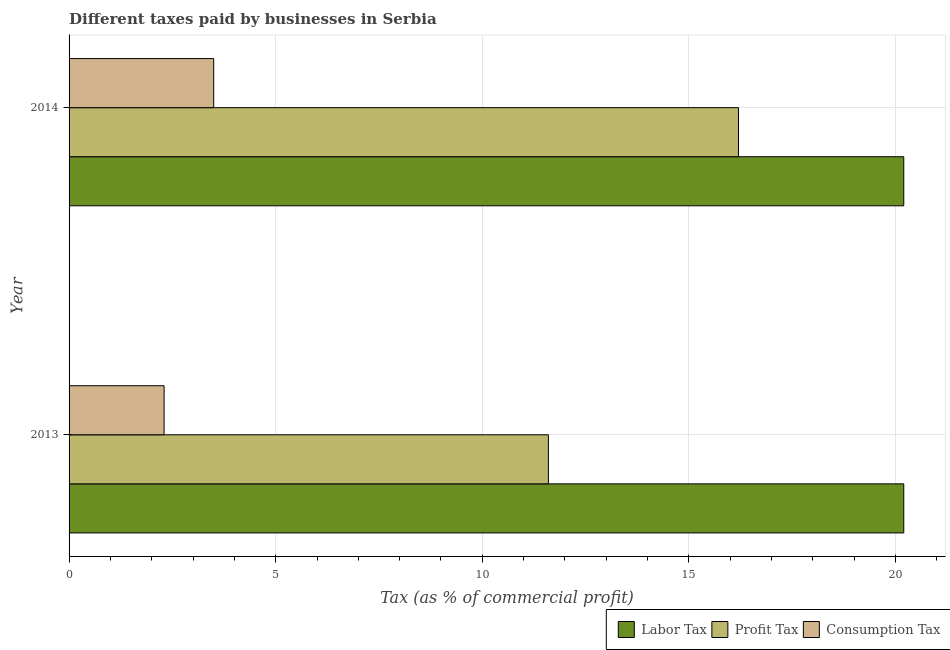Are the number of bars per tick equal to the number of legend labels?
Keep it short and to the point. Yes. Across all years, what is the maximum percentage of profit tax?
Provide a short and direct response. 16.2. Across all years, what is the minimum percentage of consumption tax?
Your answer should be compact. 2.3. What is the total percentage of profit tax in the graph?
Your answer should be compact. 27.8. What is the difference between the percentage of labor tax in 2013 and that in 2014?
Give a very brief answer. 0. What is the difference between the percentage of profit tax in 2013 and the percentage of labor tax in 2014?
Your answer should be very brief. -8.6. What is the average percentage of labor tax per year?
Ensure brevity in your answer.  20.2. In how many years, is the percentage of profit tax greater than 13 %?
Make the answer very short. 1. What is the ratio of the percentage of profit tax in 2013 to that in 2014?
Offer a very short reply. 0.72. In how many years, is the percentage of labor tax greater than the average percentage of labor tax taken over all years?
Keep it short and to the point. 0. What does the 3rd bar from the top in 2014 represents?
Keep it short and to the point. Labor Tax. What does the 2nd bar from the bottom in 2014 represents?
Give a very brief answer. Profit Tax. How many bars are there?
Provide a succinct answer. 6. Does the graph contain grids?
Provide a short and direct response. Yes. Where does the legend appear in the graph?
Your answer should be compact. Bottom right. What is the title of the graph?
Offer a terse response. Different taxes paid by businesses in Serbia. Does "Financial account" appear as one of the legend labels in the graph?
Keep it short and to the point. No. What is the label or title of the X-axis?
Your response must be concise. Tax (as % of commercial profit). What is the Tax (as % of commercial profit) in Labor Tax in 2013?
Ensure brevity in your answer.  20.2. What is the Tax (as % of commercial profit) of Consumption Tax in 2013?
Keep it short and to the point. 2.3. What is the Tax (as % of commercial profit) of Labor Tax in 2014?
Give a very brief answer. 20.2. What is the Tax (as % of commercial profit) of Profit Tax in 2014?
Give a very brief answer. 16.2. Across all years, what is the maximum Tax (as % of commercial profit) of Labor Tax?
Provide a succinct answer. 20.2. Across all years, what is the maximum Tax (as % of commercial profit) of Profit Tax?
Your answer should be compact. 16.2. Across all years, what is the minimum Tax (as % of commercial profit) in Labor Tax?
Your response must be concise. 20.2. Across all years, what is the minimum Tax (as % of commercial profit) in Profit Tax?
Offer a very short reply. 11.6. Across all years, what is the minimum Tax (as % of commercial profit) in Consumption Tax?
Your answer should be compact. 2.3. What is the total Tax (as % of commercial profit) in Labor Tax in the graph?
Your response must be concise. 40.4. What is the total Tax (as % of commercial profit) in Profit Tax in the graph?
Your answer should be compact. 27.8. What is the total Tax (as % of commercial profit) of Consumption Tax in the graph?
Offer a very short reply. 5.8. What is the difference between the Tax (as % of commercial profit) of Labor Tax in 2013 and that in 2014?
Offer a terse response. 0. What is the difference between the Tax (as % of commercial profit) of Labor Tax in 2013 and the Tax (as % of commercial profit) of Profit Tax in 2014?
Make the answer very short. 4. What is the difference between the Tax (as % of commercial profit) in Profit Tax in 2013 and the Tax (as % of commercial profit) in Consumption Tax in 2014?
Give a very brief answer. 8.1. What is the average Tax (as % of commercial profit) of Labor Tax per year?
Offer a terse response. 20.2. What is the average Tax (as % of commercial profit) in Profit Tax per year?
Your response must be concise. 13.9. What is the average Tax (as % of commercial profit) in Consumption Tax per year?
Your answer should be compact. 2.9. In the year 2014, what is the difference between the Tax (as % of commercial profit) of Labor Tax and Tax (as % of commercial profit) of Profit Tax?
Make the answer very short. 4. In the year 2014, what is the difference between the Tax (as % of commercial profit) in Labor Tax and Tax (as % of commercial profit) in Consumption Tax?
Provide a succinct answer. 16.7. What is the ratio of the Tax (as % of commercial profit) of Profit Tax in 2013 to that in 2014?
Offer a very short reply. 0.72. What is the ratio of the Tax (as % of commercial profit) in Consumption Tax in 2013 to that in 2014?
Offer a very short reply. 0.66. What is the difference between the highest and the lowest Tax (as % of commercial profit) of Labor Tax?
Keep it short and to the point. 0. 